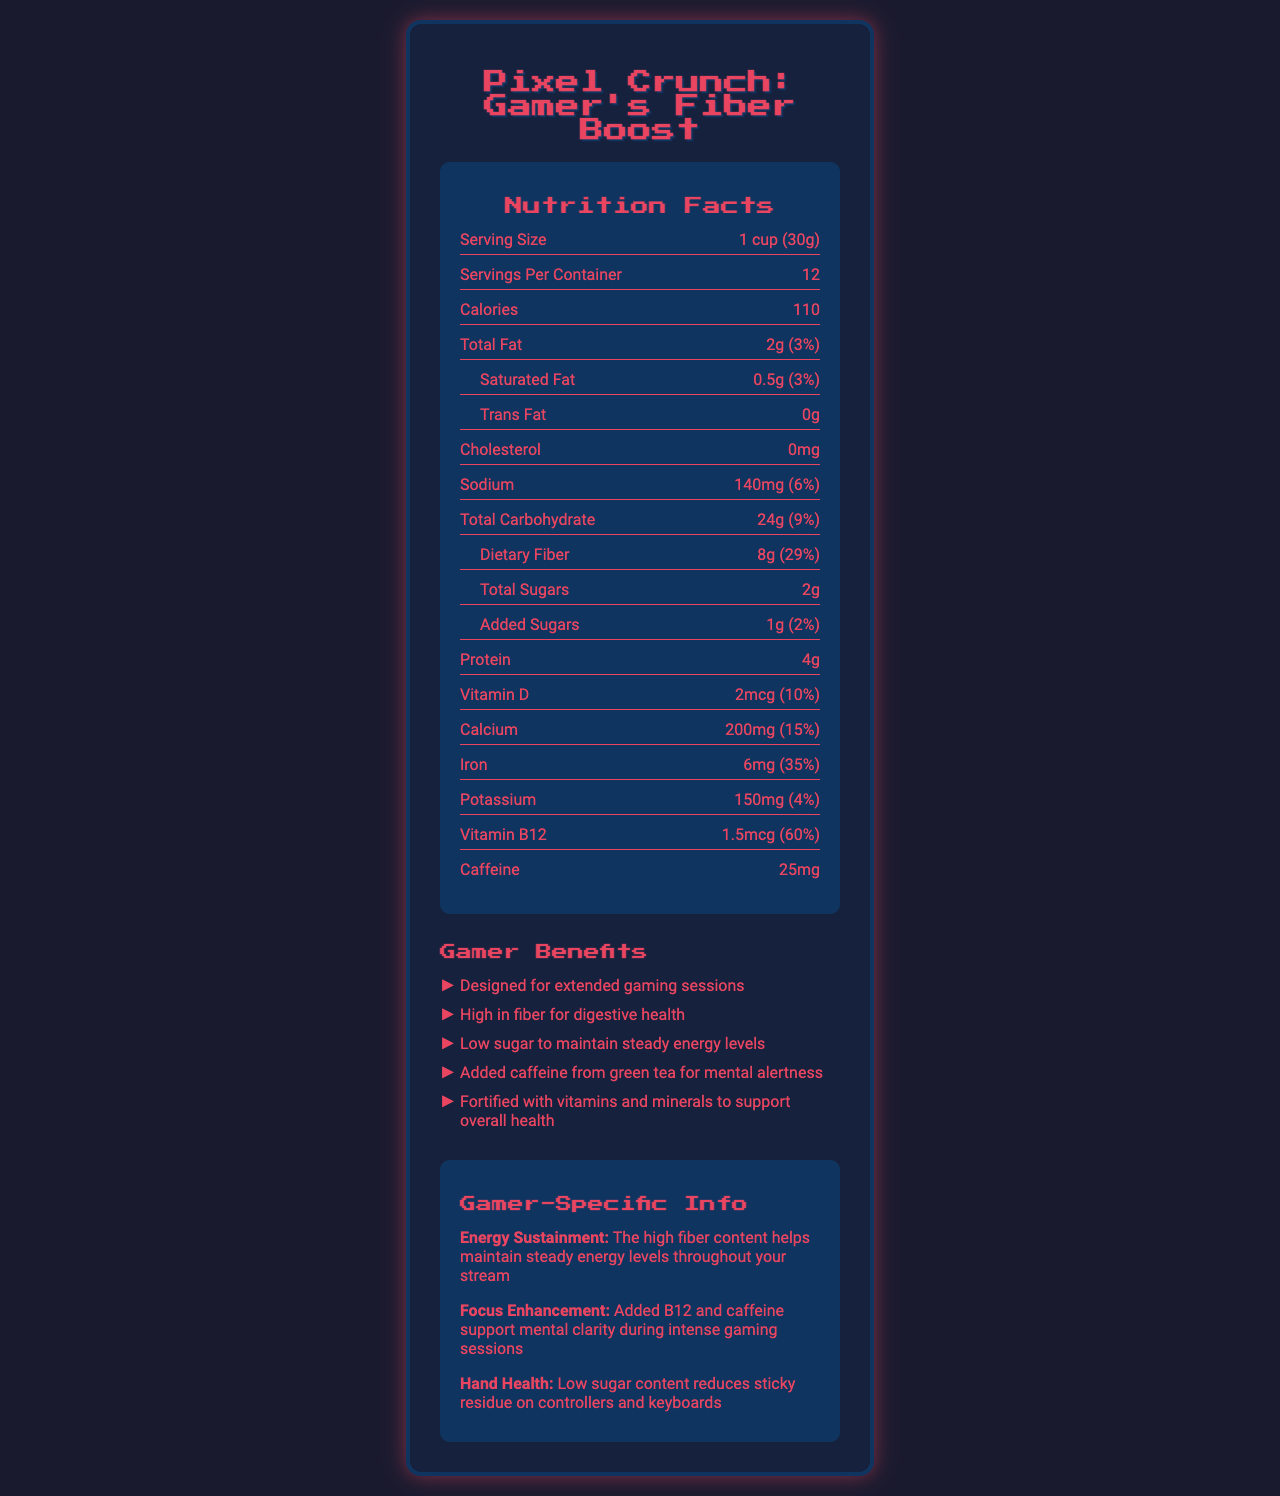what is the serving size? The serving size is listed as "1 cup (30g)" in the nutrition facts section.
Answer: 1 cup (30g) how many servings are there in a container? The document states that there are 12 servings per container.
Answer: 12 what is the amount of dietary fiber per serving? The dietary fiber content per serving is specified as 8 grams.
Answer: 8g what is the daily value percentage of calcium? The daily value percentage for calcium is noted as 15%.
Answer: 15% what are the main ingredients in Pixel Crunch: Gamer's Fiber Boost? The main ingredients are listed under the ingredients section.
Answer: Whole grain oats, Wheat bran, Rice, Pea protein, Inulin, Natural flavors, Salt, Vitamin and mineral blend (calcium carbonate, iron, vitamin B12, vitamin D), Green tea extract, Monk fruit extract Which of the following is a benefit specifically tailored for gamers? A. High in fiber B. Contains natural flavors C. Low in cholesterol D. Hand health improvement Hand health improvement is mentioned as a gamer-specific benefit, while the other options are more general claims.
Answer: D How many grams of protein are in each serving of Pixel Crunch: Gamer's Fiber Boost? A. 2g B. 4g C. 6g D. 8g The document specifies that there are 4 grams of protein per serving.
Answer: B Is there caffeine in Pixel Crunch: Gamer's Fiber Boost? The nutrition label shows that there is 25mg of caffeine per serving.
Answer: Yes Summarize the main features and benefits of Pixel Crunch: Gamer's Fiber Boost in a few sentences. The document provides a comprehensive overview of Pixel Crunch's nutritional content, ingredients, and benefits specifically tailored for gamers.
Answer: Pixel Crunch: Gamer's Fiber Boost is a low-sugar, high-fiber cereal designed for gamers and streamers. Each serving contains 110 calories, 2g of total fat, 140mg of sodium, 24g of carbohydrates with 8g of dietary fiber, and 4g of protein. It also includes vitamins and minerals such as calcium, iron, and vitamin B12, as well as 25mg of caffeine from green tea extract. The cereal claims to support sustained energy, mental clarity, and hand health during gaming sessions. What is the total amount of sugars, including added sugars, per serving? The document states that there are 2 grams of total sugars and 1 gram of added sugars, summing up to 3 grams in total.
Answer: 3g What is the daily value percentage of vitamin B12? The nutrition facts section indicates that the daily value percentage for vitamin B12 is 60%.
Answer: 60% Is there any information about whether the product is gluten-free? The document does not provide information about whether the product is gluten-free.
Answer: Cannot be determined 